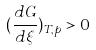<formula> <loc_0><loc_0><loc_500><loc_500>( \frac { d G } { d \xi } ) _ { T , p } > 0</formula> 